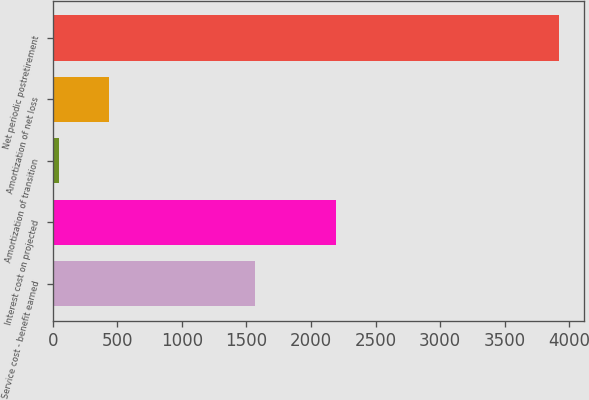<chart> <loc_0><loc_0><loc_500><loc_500><bar_chart><fcel>Service cost - benefit earned<fcel>Interest cost on projected<fcel>Amortization of transition<fcel>Amortization of net loss<fcel>Net periodic postretirement<nl><fcel>1569<fcel>2193<fcel>44<fcel>431.6<fcel>3920<nl></chart> 